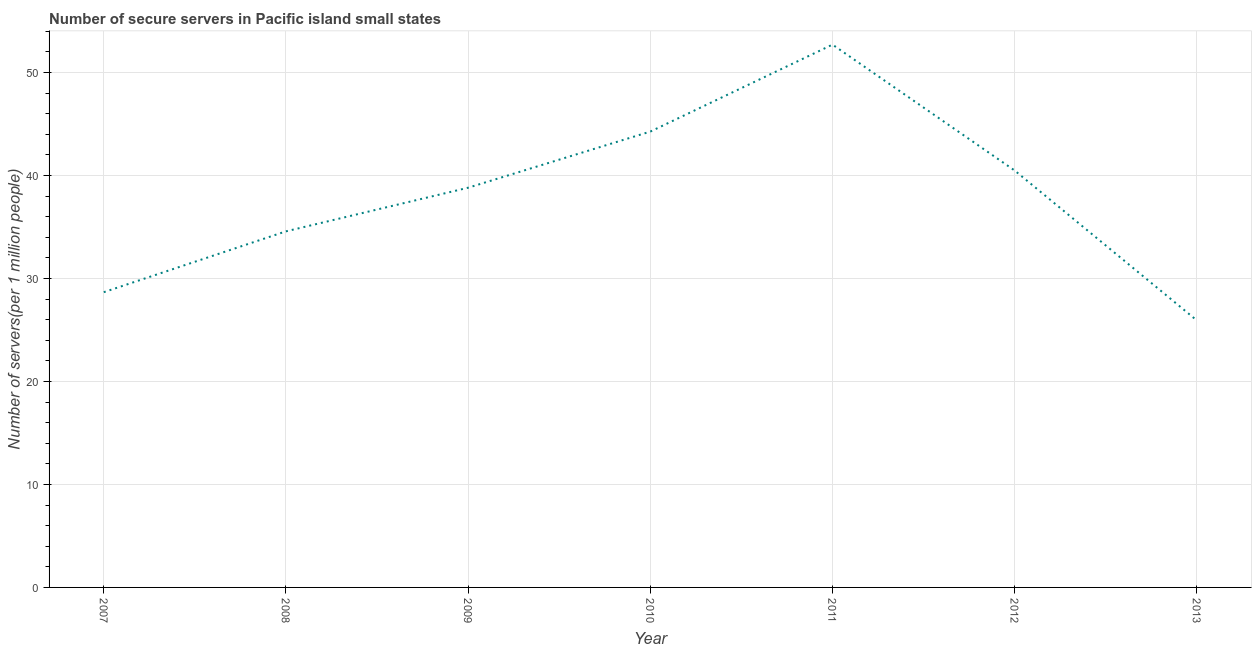What is the number of secure internet servers in 2009?
Offer a very short reply. 38.81. Across all years, what is the maximum number of secure internet servers?
Provide a succinct answer. 52.7. Across all years, what is the minimum number of secure internet servers?
Give a very brief answer. 25.92. What is the sum of the number of secure internet servers?
Make the answer very short. 265.42. What is the difference between the number of secure internet servers in 2007 and 2008?
Make the answer very short. -5.91. What is the average number of secure internet servers per year?
Offer a terse response. 37.92. What is the median number of secure internet servers?
Offer a very short reply. 38.81. In how many years, is the number of secure internet servers greater than 44 ?
Keep it short and to the point. 2. Do a majority of the years between 2013 and 2010 (inclusive) have number of secure internet servers greater than 32 ?
Provide a short and direct response. Yes. What is the ratio of the number of secure internet servers in 2009 to that in 2011?
Your answer should be very brief. 0.74. Is the number of secure internet servers in 2007 less than that in 2009?
Your response must be concise. Yes. Is the difference between the number of secure internet servers in 2007 and 2009 greater than the difference between any two years?
Offer a very short reply. No. What is the difference between the highest and the second highest number of secure internet servers?
Make the answer very short. 8.44. Is the sum of the number of secure internet servers in 2007 and 2010 greater than the maximum number of secure internet servers across all years?
Your answer should be compact. Yes. What is the difference between the highest and the lowest number of secure internet servers?
Keep it short and to the point. 26.78. In how many years, is the number of secure internet servers greater than the average number of secure internet servers taken over all years?
Offer a terse response. 4. Does the number of secure internet servers monotonically increase over the years?
Provide a short and direct response. No. How many lines are there?
Offer a very short reply. 1. What is the difference between two consecutive major ticks on the Y-axis?
Offer a terse response. 10. Are the values on the major ticks of Y-axis written in scientific E-notation?
Provide a short and direct response. No. Does the graph contain grids?
Make the answer very short. Yes. What is the title of the graph?
Your answer should be compact. Number of secure servers in Pacific island small states. What is the label or title of the X-axis?
Provide a succinct answer. Year. What is the label or title of the Y-axis?
Keep it short and to the point. Number of servers(per 1 million people). What is the Number of servers(per 1 million people) of 2007?
Provide a succinct answer. 28.67. What is the Number of servers(per 1 million people) of 2008?
Your answer should be compact. 34.57. What is the Number of servers(per 1 million people) of 2009?
Make the answer very short. 38.81. What is the Number of servers(per 1 million people) of 2010?
Ensure brevity in your answer.  44.26. What is the Number of servers(per 1 million people) of 2011?
Offer a terse response. 52.7. What is the Number of servers(per 1 million people) of 2012?
Provide a succinct answer. 40.48. What is the Number of servers(per 1 million people) of 2013?
Provide a succinct answer. 25.92. What is the difference between the Number of servers(per 1 million people) in 2007 and 2008?
Keep it short and to the point. -5.91. What is the difference between the Number of servers(per 1 million people) in 2007 and 2009?
Your answer should be compact. -10.14. What is the difference between the Number of servers(per 1 million people) in 2007 and 2010?
Ensure brevity in your answer.  -15.59. What is the difference between the Number of servers(per 1 million people) in 2007 and 2011?
Give a very brief answer. -24.04. What is the difference between the Number of servers(per 1 million people) in 2007 and 2012?
Ensure brevity in your answer.  -11.81. What is the difference between the Number of servers(per 1 million people) in 2007 and 2013?
Your answer should be compact. 2.74. What is the difference between the Number of servers(per 1 million people) in 2008 and 2009?
Your answer should be compact. -4.24. What is the difference between the Number of servers(per 1 million people) in 2008 and 2010?
Give a very brief answer. -9.69. What is the difference between the Number of servers(per 1 million people) in 2008 and 2011?
Your answer should be very brief. -18.13. What is the difference between the Number of servers(per 1 million people) in 2008 and 2012?
Make the answer very short. -5.91. What is the difference between the Number of servers(per 1 million people) in 2008 and 2013?
Provide a succinct answer. 8.65. What is the difference between the Number of servers(per 1 million people) in 2009 and 2010?
Keep it short and to the point. -5.45. What is the difference between the Number of servers(per 1 million people) in 2009 and 2011?
Offer a terse response. -13.89. What is the difference between the Number of servers(per 1 million people) in 2009 and 2012?
Offer a terse response. -1.67. What is the difference between the Number of servers(per 1 million people) in 2009 and 2013?
Offer a terse response. 12.88. What is the difference between the Number of servers(per 1 million people) in 2010 and 2011?
Your answer should be compact. -8.44. What is the difference between the Number of servers(per 1 million people) in 2010 and 2012?
Offer a terse response. 3.78. What is the difference between the Number of servers(per 1 million people) in 2010 and 2013?
Offer a terse response. 18.34. What is the difference between the Number of servers(per 1 million people) in 2011 and 2012?
Your response must be concise. 12.22. What is the difference between the Number of servers(per 1 million people) in 2011 and 2013?
Offer a very short reply. 26.78. What is the difference between the Number of servers(per 1 million people) in 2012 and 2013?
Your answer should be compact. 14.56. What is the ratio of the Number of servers(per 1 million people) in 2007 to that in 2008?
Offer a very short reply. 0.83. What is the ratio of the Number of servers(per 1 million people) in 2007 to that in 2009?
Your response must be concise. 0.74. What is the ratio of the Number of servers(per 1 million people) in 2007 to that in 2010?
Provide a short and direct response. 0.65. What is the ratio of the Number of servers(per 1 million people) in 2007 to that in 2011?
Offer a very short reply. 0.54. What is the ratio of the Number of servers(per 1 million people) in 2007 to that in 2012?
Your response must be concise. 0.71. What is the ratio of the Number of servers(per 1 million people) in 2007 to that in 2013?
Your response must be concise. 1.11. What is the ratio of the Number of servers(per 1 million people) in 2008 to that in 2009?
Your answer should be very brief. 0.89. What is the ratio of the Number of servers(per 1 million people) in 2008 to that in 2010?
Give a very brief answer. 0.78. What is the ratio of the Number of servers(per 1 million people) in 2008 to that in 2011?
Your answer should be compact. 0.66. What is the ratio of the Number of servers(per 1 million people) in 2008 to that in 2012?
Offer a very short reply. 0.85. What is the ratio of the Number of servers(per 1 million people) in 2008 to that in 2013?
Ensure brevity in your answer.  1.33. What is the ratio of the Number of servers(per 1 million people) in 2009 to that in 2010?
Ensure brevity in your answer.  0.88. What is the ratio of the Number of servers(per 1 million people) in 2009 to that in 2011?
Ensure brevity in your answer.  0.74. What is the ratio of the Number of servers(per 1 million people) in 2009 to that in 2012?
Offer a very short reply. 0.96. What is the ratio of the Number of servers(per 1 million people) in 2009 to that in 2013?
Your answer should be very brief. 1.5. What is the ratio of the Number of servers(per 1 million people) in 2010 to that in 2011?
Your response must be concise. 0.84. What is the ratio of the Number of servers(per 1 million people) in 2010 to that in 2012?
Your answer should be compact. 1.09. What is the ratio of the Number of servers(per 1 million people) in 2010 to that in 2013?
Ensure brevity in your answer.  1.71. What is the ratio of the Number of servers(per 1 million people) in 2011 to that in 2012?
Offer a terse response. 1.3. What is the ratio of the Number of servers(per 1 million people) in 2011 to that in 2013?
Keep it short and to the point. 2.03. What is the ratio of the Number of servers(per 1 million people) in 2012 to that in 2013?
Offer a very short reply. 1.56. 